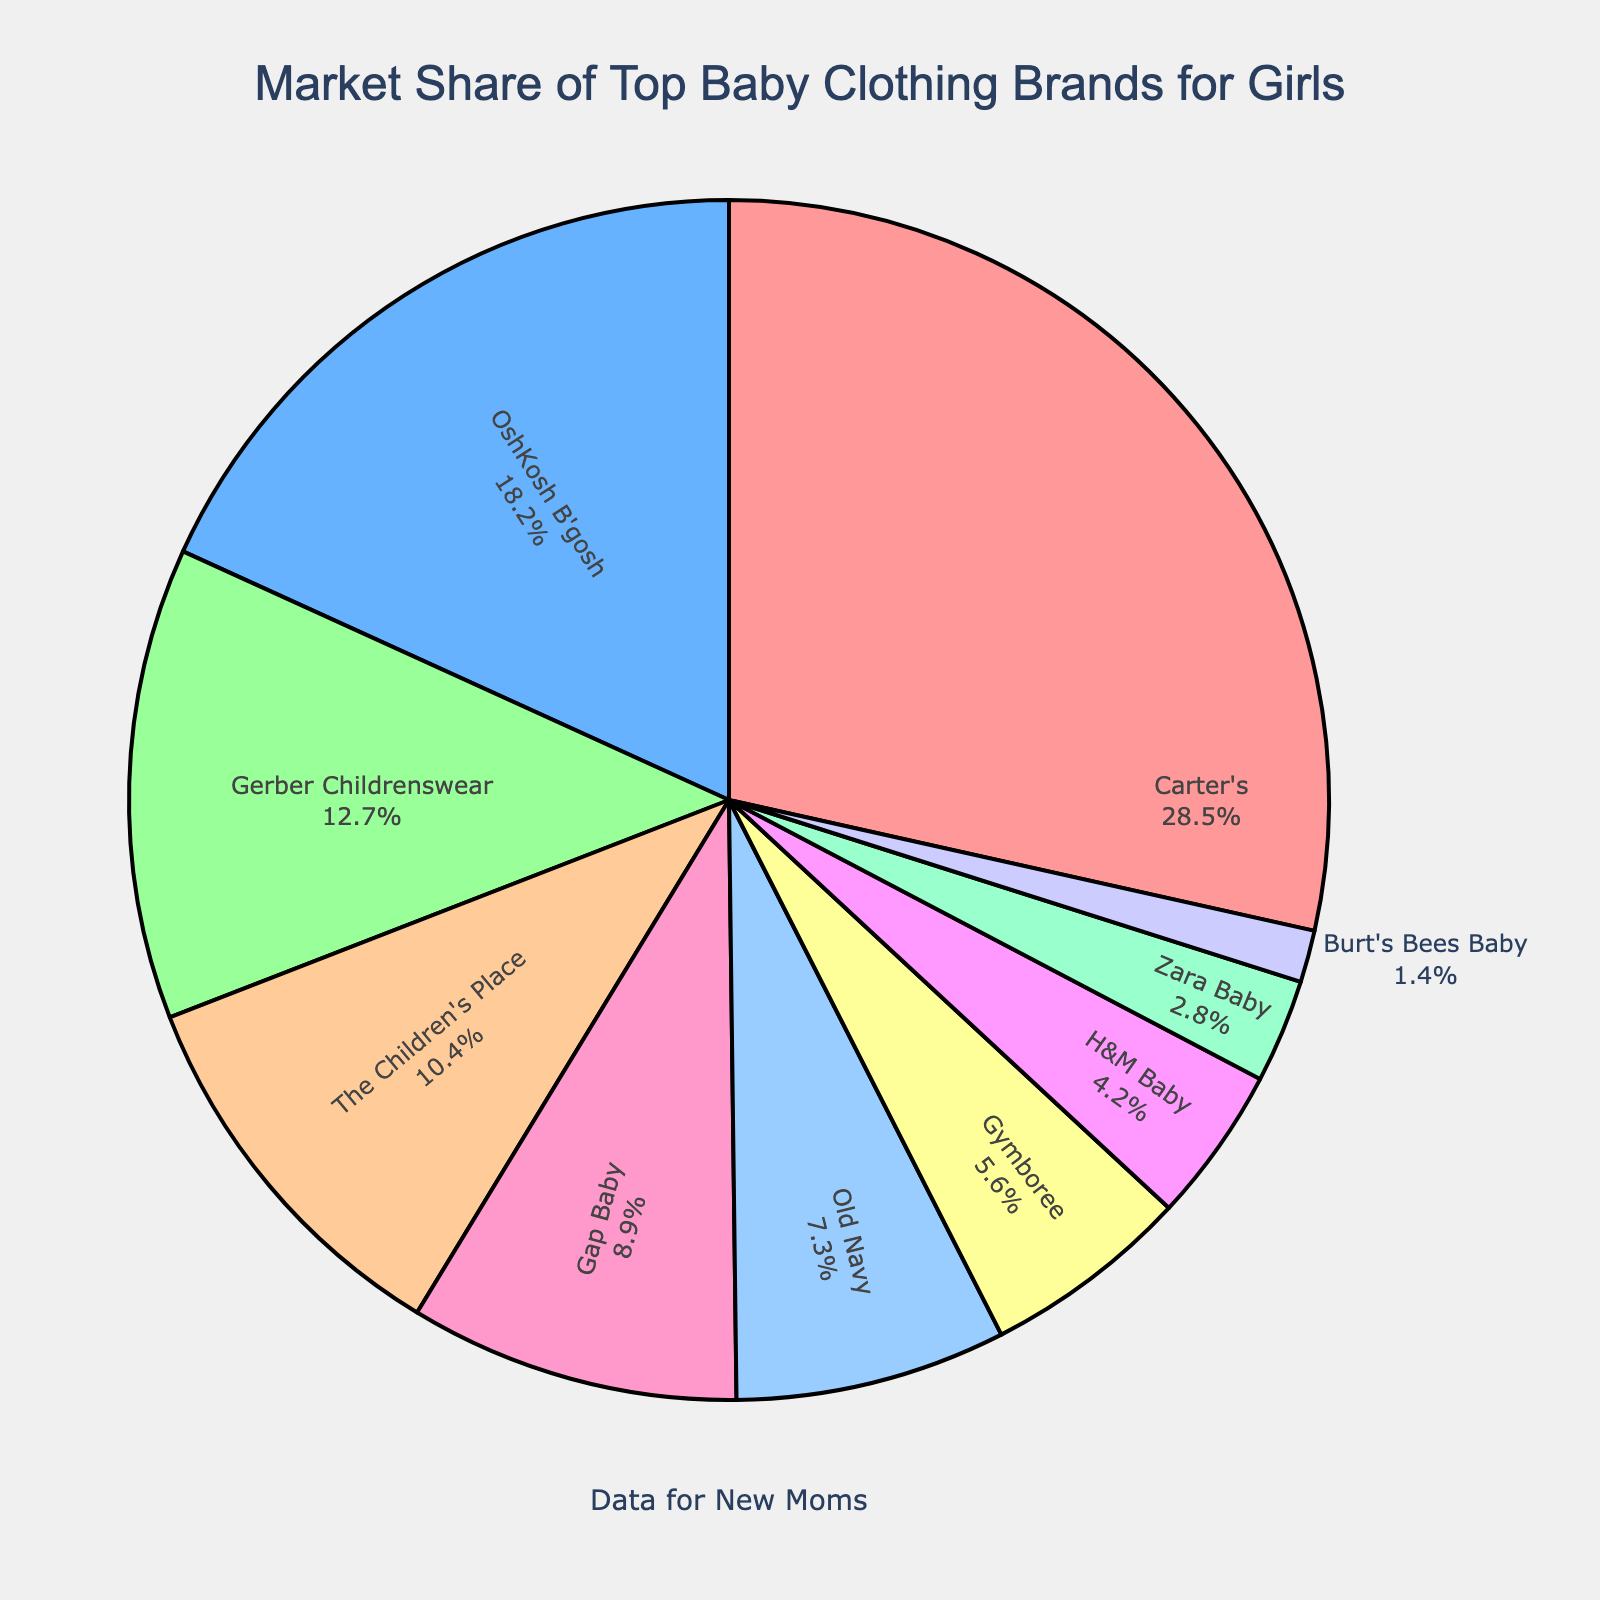Which brand has the largest market share? The largest market share can be identified by finding the brand with the highest percentage value. For this pie chart, the brand with the largest market share is Carter's at 28.5%.
Answer: Carter's What is the total market share of the top three brands? To find the total market share of the top three brands, sum their market shares: Carter's (28.5%) + OshKosh B'gosh (18.2%) + Gerber Childrenswear (12.7%) = 59.4%.
Answer: 59.4% How much larger is Carter's market share compared to The Children's Place? Subtract The Children's Place's market share from Carter's market share: 28.5% - 10.4% = 18.1%.
Answer: 18.1% Which brand has the smallest market share, and what is it? The smallest market share can be determined by identifying the brand with the lowest percentage value. The brand with the smallest market share is Burt's Bees Baby at 1.4%.
Answer: Burt's Bees Baby Are there more brands with a market share above 10% or below 10%? Count the number of brands in each category. Above 10%: Carter's, OshKosh B'gosh, Gerber Childrenswear, and The Children's Place (4 brands). Below 10%: Gap Baby, Old Navy, Gymboree, H&M Baby, Zara Baby, and Burt's Bees Baby (6 brands).
Answer: Below 10% What is the combined market share of Gap Baby, Old Navy, and Gymboree? Add the market shares of Gap Baby (8.9%), Old Navy (7.3%), and Gymboree (5.6%): 8.9% + 7.3% + 5.6% = 21.8%.
Answer: 21.8% Between Gap Baby and Old Navy, which brand has a larger market share, and by how much? Compare the market shares of Gap Baby (8.9%) and Old Navy (7.3%). Gap Baby has a larger share. The difference is 8.9% - 7.3% = 1.6%.
Answer: Gap Baby, 1.6% Which brands have a market share greater than 15%? Identify brands with market shares above 15%. These are Carter's (28.5%) and OshKosh B'gosh (18.2%).
Answer: Carter's and OshKosh B'gosh What is the average market share of the brands with more than 5% market share? First, identify the brands: Carter's, OshKosh B'gosh, Gerber Childrenswear, The Children's Place, Gap Baby, Old Navy, and Gymboree. Then calculate the average by adding their market shares and dividing by the number of these brands: (28.5 + 18.2 + 12.7 + 10.4 + 8.9 + 7.3 + 5.6) / 7 = 91.6 / 7 = 13.09%.
Answer: 13.09% 